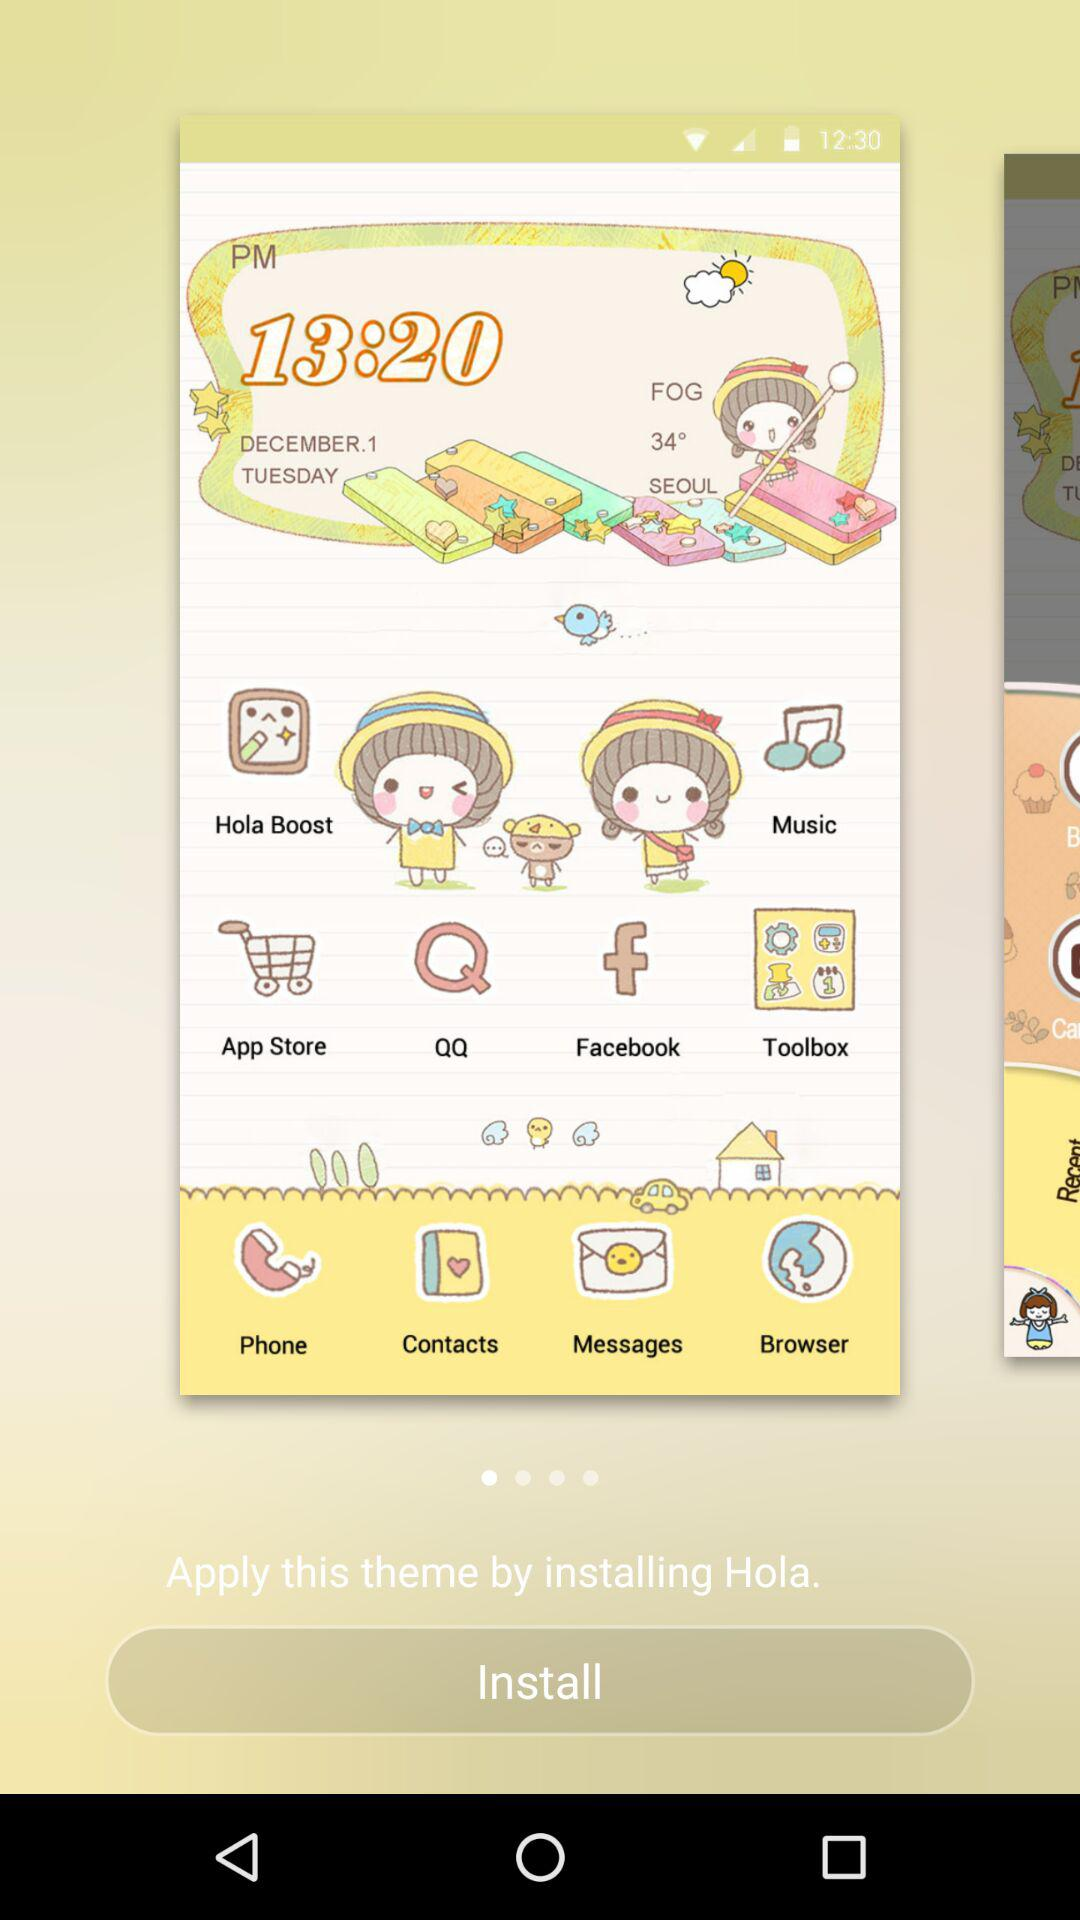What is the given time? The given time is 13:20. 